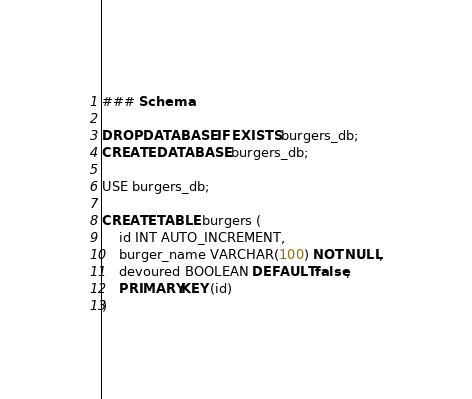<code> <loc_0><loc_0><loc_500><loc_500><_SQL_>### Schema

DROP DATABASE IF EXISTS burgers_db;
CREATE DATABASE burgers_db;

USE burgers_db;

CREATE TABLE burgers (
    id INT AUTO_INCREMENT,
    burger_name VARCHAR(100) NOT NULL,
    devoured BOOLEAN DEFAULT false,
    PRIMARY KEY (id)
)</code> 